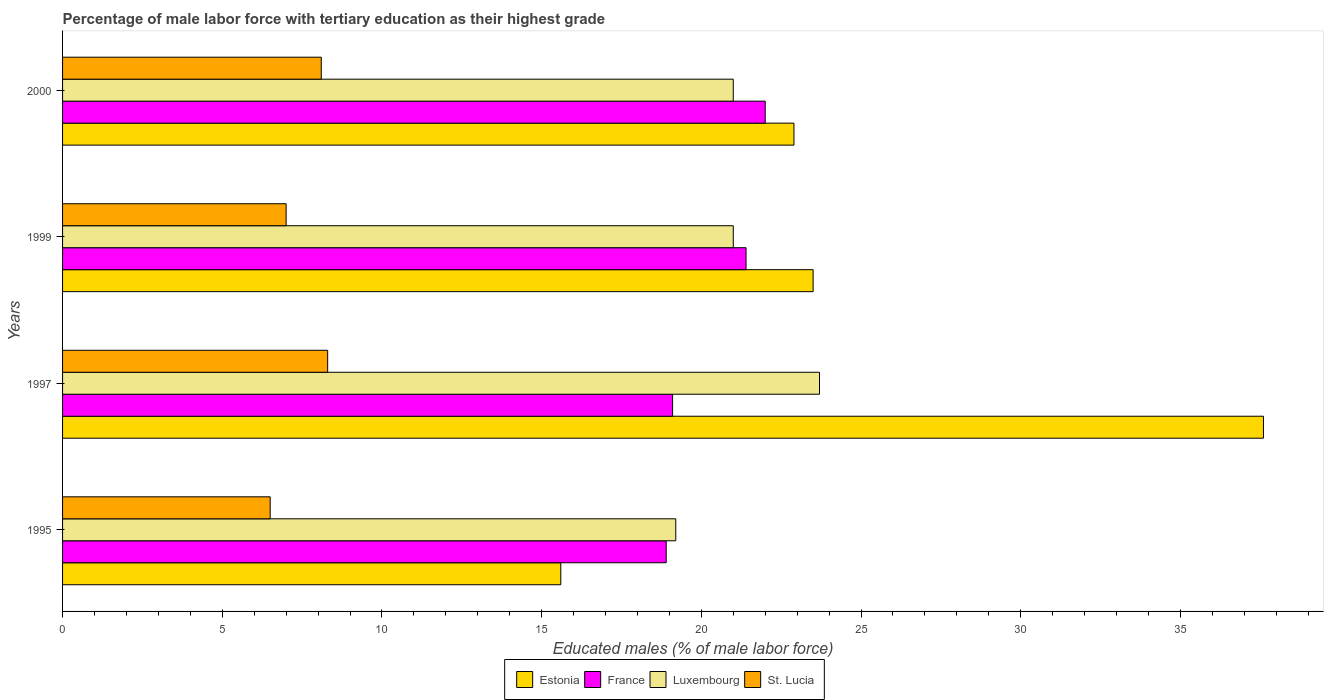How many different coloured bars are there?
Provide a succinct answer. 4. How many groups of bars are there?
Provide a short and direct response. 4. Are the number of bars per tick equal to the number of legend labels?
Offer a terse response. Yes. What is the label of the 4th group of bars from the top?
Give a very brief answer. 1995. What is the percentage of male labor force with tertiary education in Estonia in 1997?
Offer a very short reply. 37.6. Across all years, what is the maximum percentage of male labor force with tertiary education in St. Lucia?
Provide a short and direct response. 8.3. Across all years, what is the minimum percentage of male labor force with tertiary education in Luxembourg?
Offer a terse response. 19.2. In which year was the percentage of male labor force with tertiary education in France minimum?
Your answer should be very brief. 1995. What is the total percentage of male labor force with tertiary education in Luxembourg in the graph?
Make the answer very short. 84.9. What is the difference between the percentage of male labor force with tertiary education in Luxembourg in 1995 and that in 2000?
Provide a succinct answer. -1.8. What is the difference between the percentage of male labor force with tertiary education in St. Lucia in 2000 and the percentage of male labor force with tertiary education in Estonia in 1995?
Offer a terse response. -7.5. What is the average percentage of male labor force with tertiary education in St. Lucia per year?
Your answer should be very brief. 7.48. In the year 1999, what is the difference between the percentage of male labor force with tertiary education in France and percentage of male labor force with tertiary education in Luxembourg?
Ensure brevity in your answer.  0.4. In how many years, is the percentage of male labor force with tertiary education in Luxembourg greater than 10 %?
Provide a succinct answer. 4. What is the ratio of the percentage of male labor force with tertiary education in France in 1997 to that in 2000?
Your response must be concise. 0.87. Is the difference between the percentage of male labor force with tertiary education in France in 1995 and 1997 greater than the difference between the percentage of male labor force with tertiary education in Luxembourg in 1995 and 1997?
Keep it short and to the point. Yes. What is the difference between the highest and the second highest percentage of male labor force with tertiary education in France?
Ensure brevity in your answer.  0.6. In how many years, is the percentage of male labor force with tertiary education in France greater than the average percentage of male labor force with tertiary education in France taken over all years?
Your response must be concise. 2. Is the sum of the percentage of male labor force with tertiary education in France in 1995 and 2000 greater than the maximum percentage of male labor force with tertiary education in St. Lucia across all years?
Provide a succinct answer. Yes. What does the 4th bar from the top in 1997 represents?
Give a very brief answer. Estonia. What does the 3rd bar from the bottom in 1995 represents?
Provide a short and direct response. Luxembourg. How many years are there in the graph?
Provide a short and direct response. 4. What is the difference between two consecutive major ticks on the X-axis?
Provide a short and direct response. 5. Does the graph contain any zero values?
Offer a terse response. No. Does the graph contain grids?
Your response must be concise. No. What is the title of the graph?
Provide a short and direct response. Percentage of male labor force with tertiary education as their highest grade. What is the label or title of the X-axis?
Ensure brevity in your answer.  Educated males (% of male labor force). What is the label or title of the Y-axis?
Your answer should be compact. Years. What is the Educated males (% of male labor force) in Estonia in 1995?
Offer a very short reply. 15.6. What is the Educated males (% of male labor force) of France in 1995?
Provide a short and direct response. 18.9. What is the Educated males (% of male labor force) in Luxembourg in 1995?
Provide a succinct answer. 19.2. What is the Educated males (% of male labor force) in St. Lucia in 1995?
Your answer should be very brief. 6.5. What is the Educated males (% of male labor force) of Estonia in 1997?
Make the answer very short. 37.6. What is the Educated males (% of male labor force) of France in 1997?
Ensure brevity in your answer.  19.1. What is the Educated males (% of male labor force) of Luxembourg in 1997?
Your answer should be very brief. 23.7. What is the Educated males (% of male labor force) of St. Lucia in 1997?
Offer a terse response. 8.3. What is the Educated males (% of male labor force) of Estonia in 1999?
Give a very brief answer. 23.5. What is the Educated males (% of male labor force) of France in 1999?
Ensure brevity in your answer.  21.4. What is the Educated males (% of male labor force) of Luxembourg in 1999?
Provide a succinct answer. 21. What is the Educated males (% of male labor force) of Estonia in 2000?
Offer a very short reply. 22.9. What is the Educated males (% of male labor force) in France in 2000?
Give a very brief answer. 22. What is the Educated males (% of male labor force) of St. Lucia in 2000?
Keep it short and to the point. 8.1. Across all years, what is the maximum Educated males (% of male labor force) of Estonia?
Provide a succinct answer. 37.6. Across all years, what is the maximum Educated males (% of male labor force) in France?
Offer a very short reply. 22. Across all years, what is the maximum Educated males (% of male labor force) of Luxembourg?
Make the answer very short. 23.7. Across all years, what is the maximum Educated males (% of male labor force) in St. Lucia?
Ensure brevity in your answer.  8.3. Across all years, what is the minimum Educated males (% of male labor force) in Estonia?
Keep it short and to the point. 15.6. Across all years, what is the minimum Educated males (% of male labor force) of France?
Your answer should be compact. 18.9. Across all years, what is the minimum Educated males (% of male labor force) of Luxembourg?
Provide a succinct answer. 19.2. Across all years, what is the minimum Educated males (% of male labor force) of St. Lucia?
Make the answer very short. 6.5. What is the total Educated males (% of male labor force) of Estonia in the graph?
Provide a succinct answer. 99.6. What is the total Educated males (% of male labor force) in France in the graph?
Give a very brief answer. 81.4. What is the total Educated males (% of male labor force) of Luxembourg in the graph?
Offer a terse response. 84.9. What is the total Educated males (% of male labor force) of St. Lucia in the graph?
Offer a terse response. 29.9. What is the difference between the Educated males (% of male labor force) of St. Lucia in 1995 and that in 1997?
Provide a short and direct response. -1.8. What is the difference between the Educated males (% of male labor force) in Estonia in 1995 and that in 1999?
Offer a terse response. -7.9. What is the difference between the Educated males (% of male labor force) in France in 1995 and that in 1999?
Keep it short and to the point. -2.5. What is the difference between the Educated males (% of male labor force) of Luxembourg in 1995 and that in 1999?
Provide a succinct answer. -1.8. What is the difference between the Educated males (% of male labor force) in Estonia in 1995 and that in 2000?
Your answer should be very brief. -7.3. What is the difference between the Educated males (% of male labor force) of Estonia in 1997 and that in 1999?
Keep it short and to the point. 14.1. What is the difference between the Educated males (% of male labor force) in France in 1997 and that in 1999?
Provide a succinct answer. -2.3. What is the difference between the Educated males (% of male labor force) of St. Lucia in 1997 and that in 1999?
Offer a terse response. 1.3. What is the difference between the Educated males (% of male labor force) of St. Lucia in 1999 and that in 2000?
Keep it short and to the point. -1.1. What is the difference between the Educated males (% of male labor force) in Estonia in 1995 and the Educated males (% of male labor force) in France in 1997?
Provide a succinct answer. -3.5. What is the difference between the Educated males (% of male labor force) in Estonia in 1995 and the Educated males (% of male labor force) in St. Lucia in 1997?
Keep it short and to the point. 7.3. What is the difference between the Educated males (% of male labor force) of France in 1995 and the Educated males (% of male labor force) of Luxembourg in 1997?
Make the answer very short. -4.8. What is the difference between the Educated males (% of male labor force) of France in 1995 and the Educated males (% of male labor force) of St. Lucia in 1997?
Offer a very short reply. 10.6. What is the difference between the Educated males (% of male labor force) in Estonia in 1995 and the Educated males (% of male labor force) in France in 1999?
Provide a short and direct response. -5.8. What is the difference between the Educated males (% of male labor force) in France in 1995 and the Educated males (% of male labor force) in St. Lucia in 1999?
Make the answer very short. 11.9. What is the difference between the Educated males (% of male labor force) in Luxembourg in 1995 and the Educated males (% of male labor force) in St. Lucia in 1999?
Offer a terse response. 12.2. What is the difference between the Educated males (% of male labor force) of Estonia in 1995 and the Educated males (% of male labor force) of St. Lucia in 2000?
Ensure brevity in your answer.  7.5. What is the difference between the Educated males (% of male labor force) of France in 1995 and the Educated males (% of male labor force) of Luxembourg in 2000?
Make the answer very short. -2.1. What is the difference between the Educated males (% of male labor force) of Estonia in 1997 and the Educated males (% of male labor force) of Luxembourg in 1999?
Your answer should be very brief. 16.6. What is the difference between the Educated males (% of male labor force) in Estonia in 1997 and the Educated males (% of male labor force) in St. Lucia in 1999?
Keep it short and to the point. 30.6. What is the difference between the Educated males (% of male labor force) in France in 1997 and the Educated males (% of male labor force) in St. Lucia in 1999?
Your response must be concise. 12.1. What is the difference between the Educated males (% of male labor force) in Estonia in 1997 and the Educated males (% of male labor force) in France in 2000?
Keep it short and to the point. 15.6. What is the difference between the Educated males (% of male labor force) in Estonia in 1997 and the Educated males (% of male labor force) in St. Lucia in 2000?
Keep it short and to the point. 29.5. What is the difference between the Educated males (% of male labor force) of France in 1997 and the Educated males (% of male labor force) of St. Lucia in 2000?
Provide a succinct answer. 11. What is the difference between the Educated males (% of male labor force) in France in 1999 and the Educated males (% of male labor force) in Luxembourg in 2000?
Give a very brief answer. 0.4. What is the difference between the Educated males (% of male labor force) of France in 1999 and the Educated males (% of male labor force) of St. Lucia in 2000?
Give a very brief answer. 13.3. What is the average Educated males (% of male labor force) of Estonia per year?
Make the answer very short. 24.9. What is the average Educated males (% of male labor force) of France per year?
Make the answer very short. 20.35. What is the average Educated males (% of male labor force) in Luxembourg per year?
Make the answer very short. 21.23. What is the average Educated males (% of male labor force) of St. Lucia per year?
Your answer should be compact. 7.47. In the year 1995, what is the difference between the Educated males (% of male labor force) in Estonia and Educated males (% of male labor force) in France?
Give a very brief answer. -3.3. In the year 1995, what is the difference between the Educated males (% of male labor force) in Estonia and Educated males (% of male labor force) in St. Lucia?
Make the answer very short. 9.1. In the year 1995, what is the difference between the Educated males (% of male labor force) in Luxembourg and Educated males (% of male labor force) in St. Lucia?
Offer a very short reply. 12.7. In the year 1997, what is the difference between the Educated males (% of male labor force) in Estonia and Educated males (% of male labor force) in France?
Make the answer very short. 18.5. In the year 1997, what is the difference between the Educated males (% of male labor force) of Estonia and Educated males (% of male labor force) of Luxembourg?
Provide a succinct answer. 13.9. In the year 1997, what is the difference between the Educated males (% of male labor force) of Estonia and Educated males (% of male labor force) of St. Lucia?
Your response must be concise. 29.3. In the year 1997, what is the difference between the Educated males (% of male labor force) in France and Educated males (% of male labor force) in St. Lucia?
Make the answer very short. 10.8. In the year 1999, what is the difference between the Educated males (% of male labor force) in Estonia and Educated males (% of male labor force) in Luxembourg?
Your response must be concise. 2.5. In the year 1999, what is the difference between the Educated males (% of male labor force) of France and Educated males (% of male labor force) of Luxembourg?
Provide a short and direct response. 0.4. In the year 1999, what is the difference between the Educated males (% of male labor force) of France and Educated males (% of male labor force) of St. Lucia?
Keep it short and to the point. 14.4. In the year 1999, what is the difference between the Educated males (% of male labor force) of Luxembourg and Educated males (% of male labor force) of St. Lucia?
Give a very brief answer. 14. In the year 2000, what is the difference between the Educated males (% of male labor force) of France and Educated males (% of male labor force) of Luxembourg?
Make the answer very short. 1. What is the ratio of the Educated males (% of male labor force) of Estonia in 1995 to that in 1997?
Provide a short and direct response. 0.41. What is the ratio of the Educated males (% of male labor force) of Luxembourg in 1995 to that in 1997?
Keep it short and to the point. 0.81. What is the ratio of the Educated males (% of male labor force) in St. Lucia in 1995 to that in 1997?
Offer a very short reply. 0.78. What is the ratio of the Educated males (% of male labor force) in Estonia in 1995 to that in 1999?
Keep it short and to the point. 0.66. What is the ratio of the Educated males (% of male labor force) of France in 1995 to that in 1999?
Your answer should be compact. 0.88. What is the ratio of the Educated males (% of male labor force) in Luxembourg in 1995 to that in 1999?
Your answer should be compact. 0.91. What is the ratio of the Educated males (% of male labor force) in Estonia in 1995 to that in 2000?
Keep it short and to the point. 0.68. What is the ratio of the Educated males (% of male labor force) in France in 1995 to that in 2000?
Your answer should be very brief. 0.86. What is the ratio of the Educated males (% of male labor force) in Luxembourg in 1995 to that in 2000?
Keep it short and to the point. 0.91. What is the ratio of the Educated males (% of male labor force) in St. Lucia in 1995 to that in 2000?
Provide a succinct answer. 0.8. What is the ratio of the Educated males (% of male labor force) in Estonia in 1997 to that in 1999?
Ensure brevity in your answer.  1.6. What is the ratio of the Educated males (% of male labor force) in France in 1997 to that in 1999?
Provide a short and direct response. 0.89. What is the ratio of the Educated males (% of male labor force) in Luxembourg in 1997 to that in 1999?
Offer a terse response. 1.13. What is the ratio of the Educated males (% of male labor force) of St. Lucia in 1997 to that in 1999?
Provide a short and direct response. 1.19. What is the ratio of the Educated males (% of male labor force) in Estonia in 1997 to that in 2000?
Offer a very short reply. 1.64. What is the ratio of the Educated males (% of male labor force) of France in 1997 to that in 2000?
Your answer should be very brief. 0.87. What is the ratio of the Educated males (% of male labor force) of Luxembourg in 1997 to that in 2000?
Provide a succinct answer. 1.13. What is the ratio of the Educated males (% of male labor force) of St. Lucia in 1997 to that in 2000?
Ensure brevity in your answer.  1.02. What is the ratio of the Educated males (% of male labor force) in Estonia in 1999 to that in 2000?
Offer a very short reply. 1.03. What is the ratio of the Educated males (% of male labor force) of France in 1999 to that in 2000?
Your answer should be very brief. 0.97. What is the ratio of the Educated males (% of male labor force) in St. Lucia in 1999 to that in 2000?
Keep it short and to the point. 0.86. What is the difference between the highest and the second highest Educated males (% of male labor force) in France?
Your response must be concise. 0.6. What is the difference between the highest and the second highest Educated males (% of male labor force) in Luxembourg?
Your answer should be compact. 2.7. What is the difference between the highest and the lowest Educated males (% of male labor force) in Estonia?
Offer a very short reply. 22. What is the difference between the highest and the lowest Educated males (% of male labor force) of St. Lucia?
Keep it short and to the point. 1.8. 